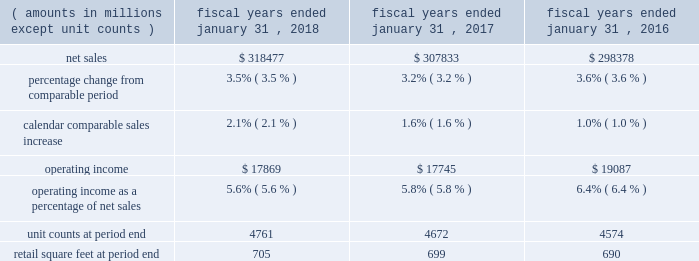Continued investments in ecommerce and technology .
The increase in operating expenses as a percentage of net sales for fiscal 2017 was partially offset by the impact of store closures in the fourth quarter of fiscal 2016 .
Membership and other income was relatively flat for fiscal 2018 and increased $ 1.0 billion a0for fiscal 2017 , when compared to the same period in the previous fiscal year .
While fiscal 2018 included a $ 387 million gain from the sale of suburbia , a $ 47 million gain from a land sale , higher recycling income from our sustainability efforts and higher membership income from increased plus member penetration at sam's club , these gains were less than gains recognized in fiscal 2017 .
Fiscal 2017 included a $ 535 million gain from the sale of our yihaodian business and a $ 194 million gain from the sale of shopping malls in chile .
For fiscal 2018 , loss on extinguishment of debt was a0$ 3.1 billion , due to the early extinguishment of long-term debt which allowed us to retire higher rate debt to reduce interest expense in future periods .
Our effective income tax rate was 30.4% ( 30.4 % ) for fiscal 2018 and 30.3% ( 30.3 % ) for both fiscal 2017 and 2016 .
Although relatively consistent year-over-year , our effective income tax rate may fluctuate from period to period as a result of factors including changes in our assessment of certain tax contingencies , valuation allowances , changes in tax laws , outcomes of administrative audits , the impact of discrete items and the mix of earnings among our u.s .
Operations and international operations .
The reconciliation from the u.s .
Statutory rate to the effective income tax rates for fiscal 2018 , 2017 and 2016 is presented in note 9 in the "notes to consolidated financial statements" and describes the impact of the enactment of the tax cuts and jobs act of 2017 ( the "tax act" ) to the fiscal 2018 effective income tax rate .
As a result of the factors discussed above , we reported $ 10.5 billion and $ 14.3 billion of consolidated net income for fiscal 2018 and 2017 , respectively , which represents a decrease of $ 3.8 billion and $ 0.8 billion for fiscal 2018 and 2017 , respectively , when compared to the previous fiscal year .
Diluted net income per common share attributable to walmart ( "eps" ) was $ 3.28 and $ 4.38 for fiscal 2018 and 2017 , respectively .
Walmart u.s .
Segment .
Net sales for the walmart u.s .
Segment increased $ 10.6 billion or 3.5% ( 3.5 % ) and $ 9.5 billion or 3.2% ( 3.2 % ) for fiscal 2018 and 2017 , respectively , when compared to the previous fiscal year .
The increases in net sales were primarily due to increases in comparable store sales of 2.1% ( 2.1 % ) and 1.6% ( 1.6 % ) for fiscal 2018 and 2017 , respectively , and year-over-year growth in retail square feet of 0.7% ( 0.7 % ) and 1.4% ( 1.4 % ) for fiscal 2018 and 2017 , respectively .
Additionally , for fiscal 2018 , sales generated from ecommerce acquisitions further contributed to the year-over-year increase .
Gross profit rate decreased 24 basis points for fiscal 2018 and increased 24 basis points for fiscal 2017 , when compared to the previous fiscal year .
For fiscal 2018 , the decrease was primarily due to strategic price investments and the mix impact from ecommerce .
Partially offsetting the negative factors for fiscal 2018 was the positive impact of savings from procuring merchandise .
For fiscal 2017 , the increase in gross profit rate was primarily due to improved margin in food and consumables , including the impact of savings in procuring merchandise and lower transportation expense from lower fuel costs .
Operating expenses as a percentage of segment net sales was relatively flat for fiscal 2018 and increased 101 basis points for fiscal 2017 , when compared to the previous fiscal year .
Fiscal 2018 and fiscal 2017 included charges related to discontinued real estate projects of $ 244 million and $ 249 million , respectively .
For fiscal 2017 , the increase was primarily driven by an increase in wage expense due to the investment in the associate wage structure ; the charge related to discontinued real estate projects ; and investments in digital retail and technology .
The increase in operating expenses as a percentage of segment net sales for fiscal 2017 was partially offset by the impact of store closures in fiscal 2016 .
As a result of the factors discussed above , segment operating income increased $ 124 million for fiscal 2018 and decreased $ 1.3 billion for fiscal 2017 , respectively. .
What was the percentage change in net sales from 2017 to 2018? 
Computations: ((318477 - 307833) / 307833)
Answer: 0.03458. 